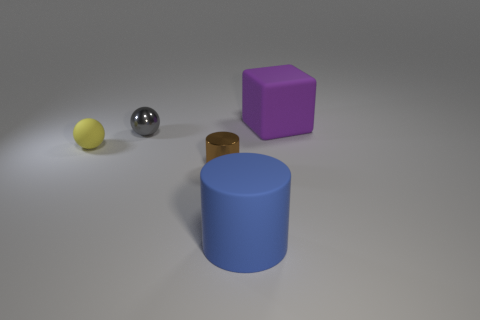Subtract all gray cylinders. Subtract all brown blocks. How many cylinders are left? 2 Add 2 large red metallic balls. How many objects exist? 7 Subtract all cylinders. How many objects are left? 3 Add 2 big purple cubes. How many big purple cubes exist? 3 Subtract 0 red cubes. How many objects are left? 5 Subtract all purple rubber balls. Subtract all tiny gray shiny things. How many objects are left? 4 Add 3 tiny gray shiny things. How many tiny gray shiny things are left? 4 